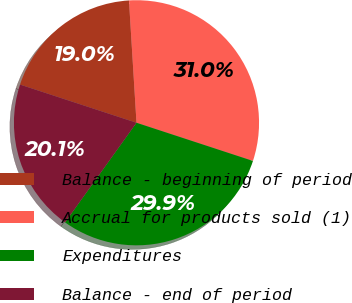Convert chart to OTSL. <chart><loc_0><loc_0><loc_500><loc_500><pie_chart><fcel>Balance - beginning of period<fcel>Accrual for products sold (1)<fcel>Expenditures<fcel>Balance - end of period<nl><fcel>18.98%<fcel>31.02%<fcel>29.86%<fcel>20.14%<nl></chart> 